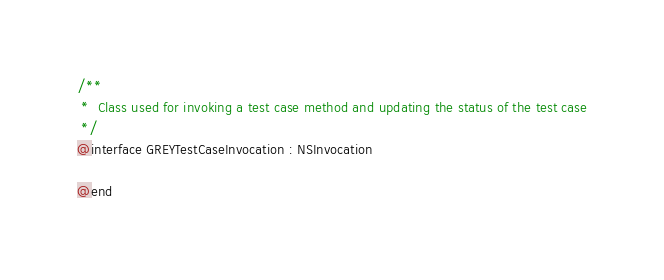<code> <loc_0><loc_0><loc_500><loc_500><_C_>
/**
 *  Class used for invoking a test case method and updating the status of the test case
 */
@interface GREYTestCaseInvocation : NSInvocation

@end

</code> 